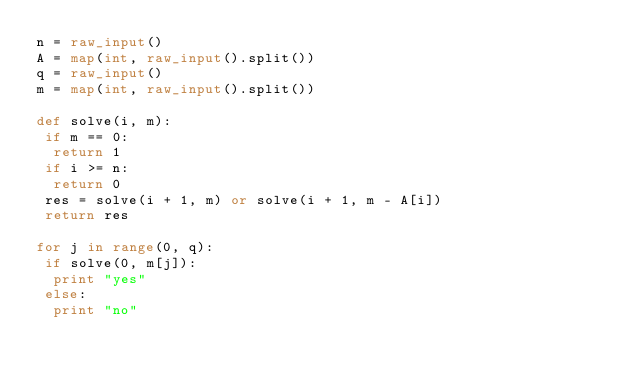<code> <loc_0><loc_0><loc_500><loc_500><_Python_>n = raw_input()
A = map(int, raw_input().split())
q = raw_input()
m = map(int, raw_input().split())

def solve(i, m):
 if m == 0:
  return 1
 if i >= n:
  return 0
 res = solve(i + 1, m) or solve(i + 1, m - A[i])
 return res

for j in range(0, q):
 if solve(0, m[j]):
  print "yes"
 else:
  print "no"</code> 